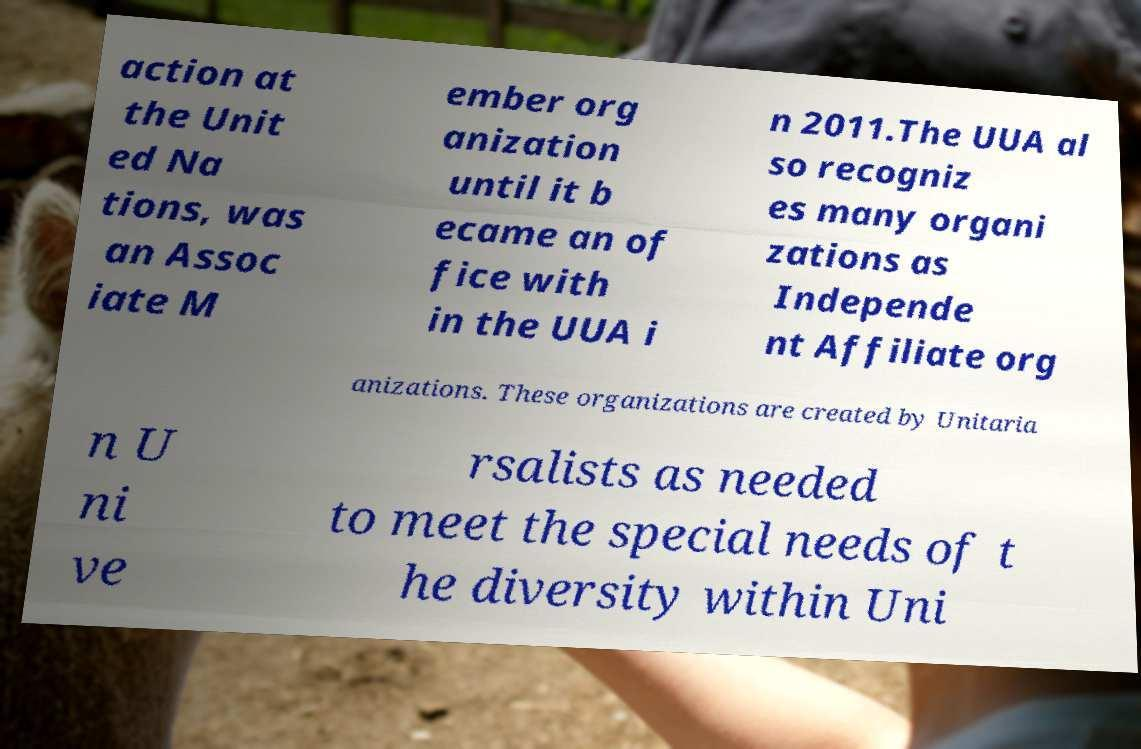There's text embedded in this image that I need extracted. Can you transcribe it verbatim? action at the Unit ed Na tions, was an Assoc iate M ember org anization until it b ecame an of fice with in the UUA i n 2011.The UUA al so recogniz es many organi zations as Independe nt Affiliate org anizations. These organizations are created by Unitaria n U ni ve rsalists as needed to meet the special needs of t he diversity within Uni 